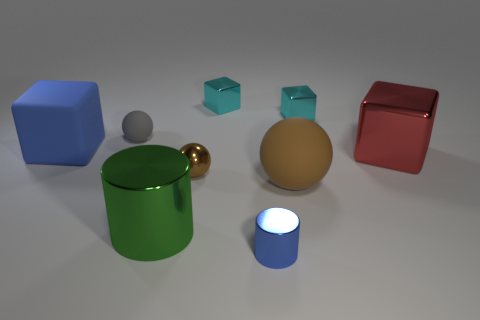Are there the same number of tiny cylinders that are behind the tiny blue object and shiny balls to the right of the tiny brown object?
Your answer should be very brief. Yes. Does the green thing have the same shape as the big blue thing?
Offer a terse response. No. What is the big thing that is both behind the big brown matte sphere and right of the big metallic cylinder made of?
Your answer should be very brief. Metal. How many big brown things are the same shape as the tiny blue shiny object?
Offer a very short reply. 0. There is a sphere behind the big cube left of the tiny cyan object that is to the left of the blue shiny thing; what size is it?
Give a very brief answer. Small. Is the number of cyan objects to the left of the large rubber sphere greater than the number of big brown rubber balls?
Offer a very short reply. No. Are there any large blue spheres?
Ensure brevity in your answer.  No. How many rubber things are the same size as the brown matte sphere?
Your answer should be very brief. 1. Is the number of big green cylinders behind the brown metallic thing greater than the number of blue cylinders right of the large brown rubber object?
Your answer should be compact. No. There is a blue cylinder that is the same size as the brown shiny sphere; what is its material?
Give a very brief answer. Metal. 